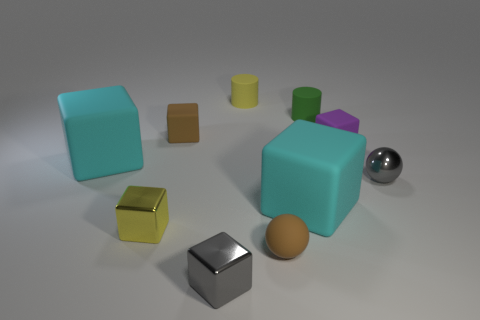Does the cyan block right of the small yellow matte cylinder have the same size as the thing that is behind the green matte object?
Give a very brief answer. No. Is there a cyan matte object of the same shape as the green rubber object?
Keep it short and to the point. No. Are there fewer tiny brown matte balls that are behind the yellow rubber object than large cubes?
Offer a terse response. Yes. Does the tiny purple thing have the same shape as the small yellow matte object?
Provide a succinct answer. No. What size is the cyan matte cube that is on the left side of the gray metallic cube?
Your answer should be compact. Large. The yellow object that is the same material as the green object is what size?
Your answer should be very brief. Small. Is the number of small purple rubber things less than the number of tiny matte objects?
Ensure brevity in your answer.  Yes. What is the material of the purple thing that is the same size as the metal sphere?
Keep it short and to the point. Rubber. Are there more tiny blocks than large green cylinders?
Your answer should be compact. Yes. How many other things are there of the same color as the shiny ball?
Your answer should be compact. 1. 